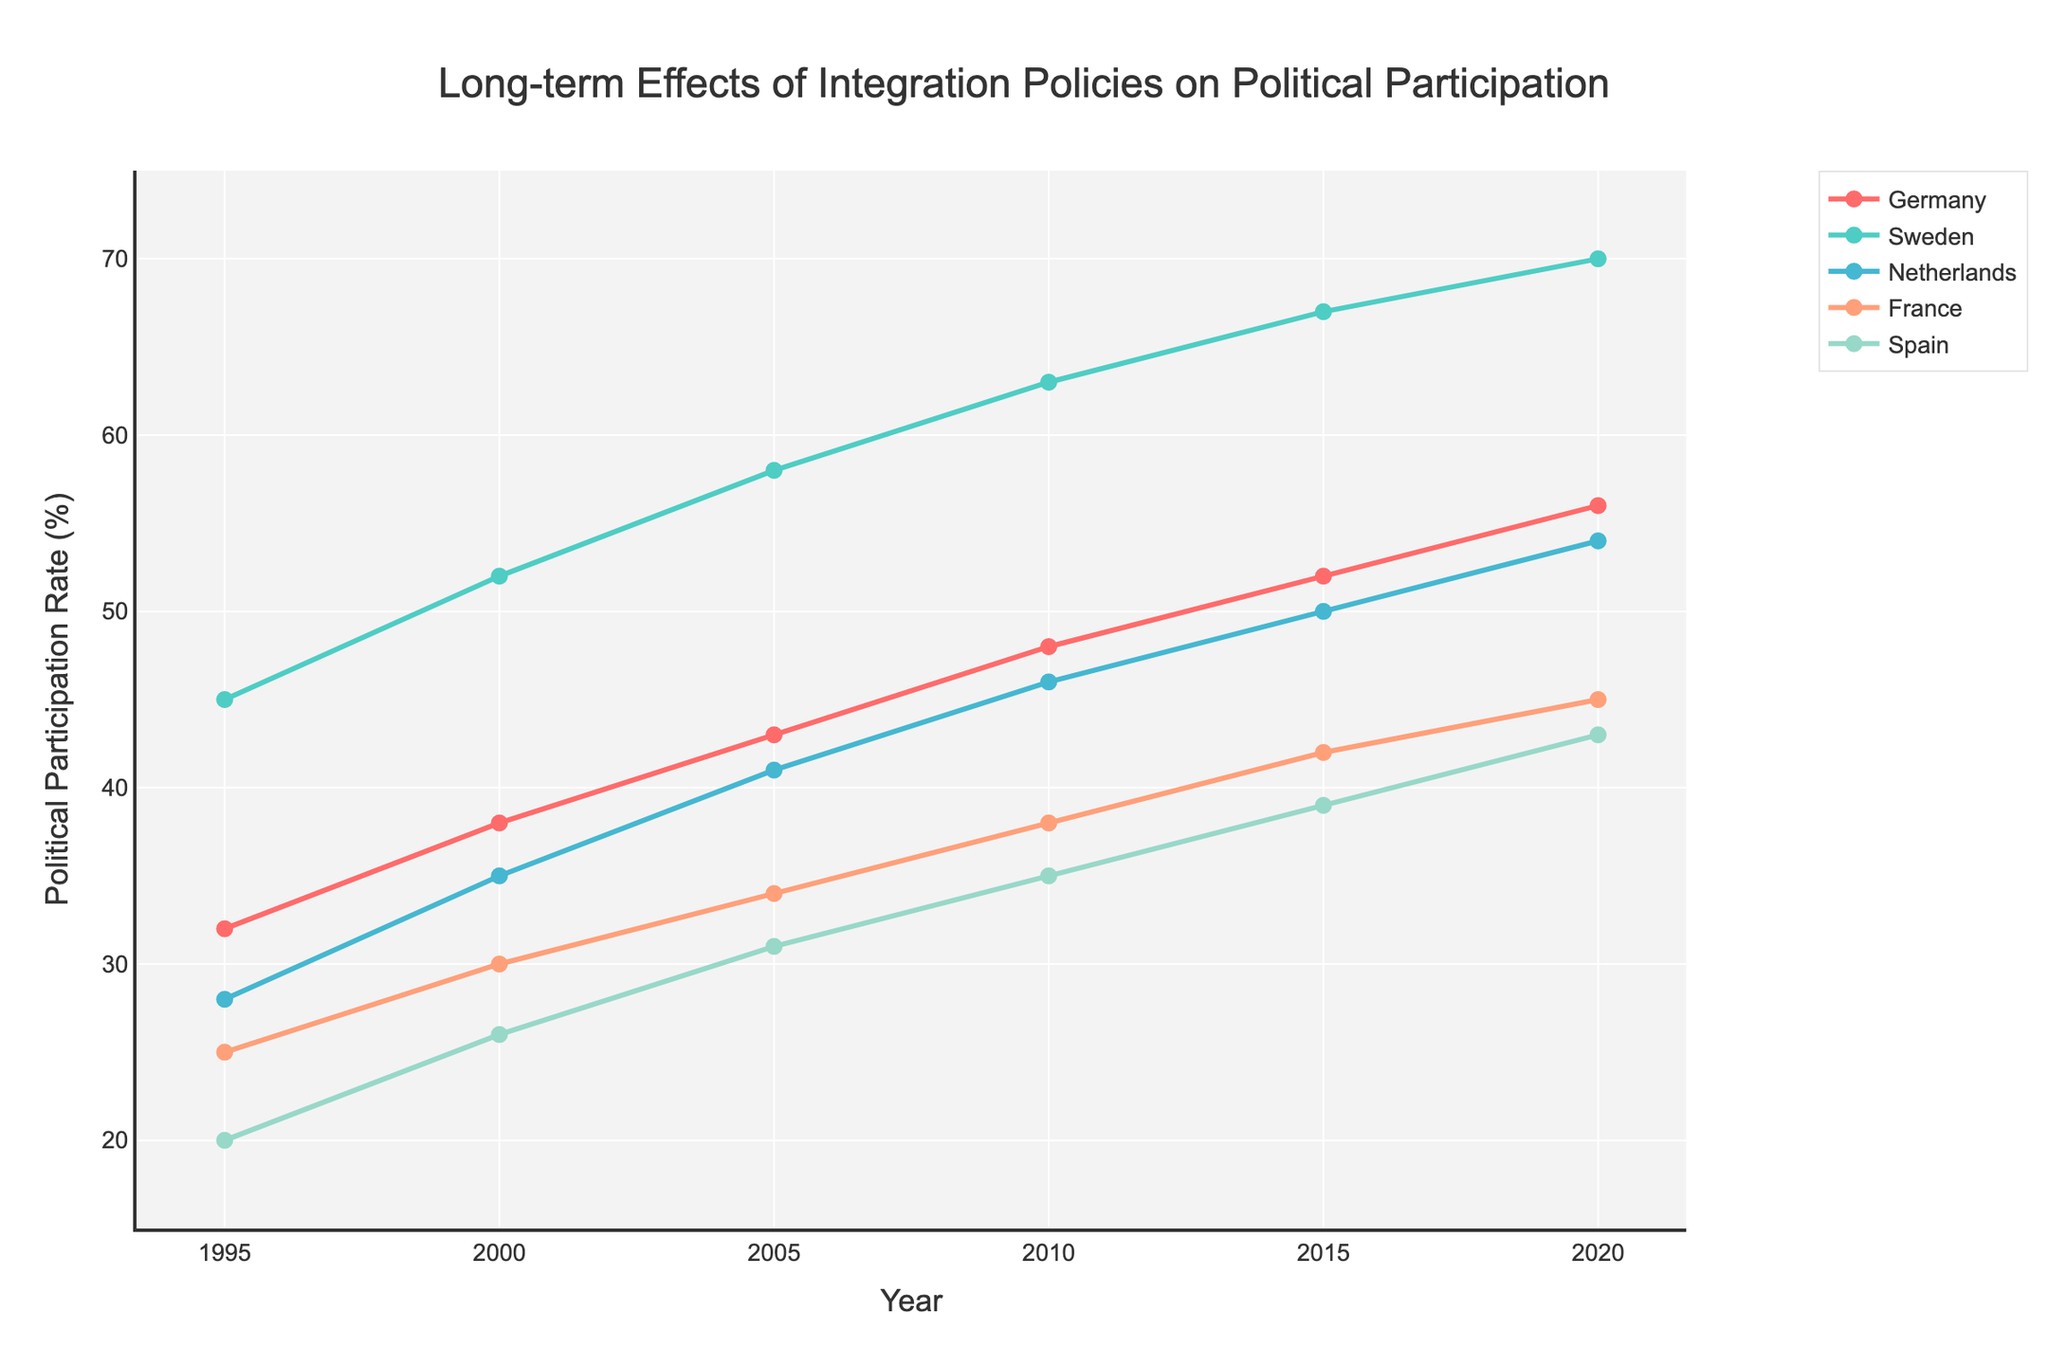What is the political participation rate in Germany in 2000? Refer to the political participation rate for Germany in the year 2000 on the plot.
Answer: 38 Which country had the highest political participation rate in 2020? Look at the political participation rates for all countries in the year 2020 and compare them.
Answer: Sweden How did the political participation rate in Spain change from 1995 to 2020? Determine the difference between the political participation rates for Spain in 1995 and 2020.
Answer: Increased by 23% Between Germany and Netherlands, which country had a higher increase in political participation rate from 1995 to 2020? Calculate the increase for each country by subtracting the 1995 rate from the 2020 rate, then compare the two results.
Answer: Germany What is the average political participation rate in France from 1995 to 2020? Sum the political participation rates of France for each year and divide by the number of years to find the average.
Answer: 35.67 Which year shows the smallest difference in political participation rates between France and Spain? Calculate the absolute difference between the rates of France and Spain for each year and identify the smallest value.
Answer: 2020 Describe the trend in Sweden's political participation rate from 1995 to 2020. Observe the change in Sweden's political participation rate over the years, noting whether it increased, decreased, or remained stable.
Answer: Increased consistently What is the total increase in political participation rate for the Netherlands from 1995 to 2020? Subtract the 1995 participation rate for the Netherlands from the 2020 participation rate.
Answer: 26 Which country had the most consistent increase in political participation rates over the years? Examine the trend lines for each country and determine which exhibits the smoothest and most steady upward trajectory.
Answer: Sweden How does the political participation rate in 2015 for Sweden compare to that of Germany in the same year? Compare the data points for Sweden and Germany in the year 2015.
Answer: Sweden's rate is 15% higher than Germany's 